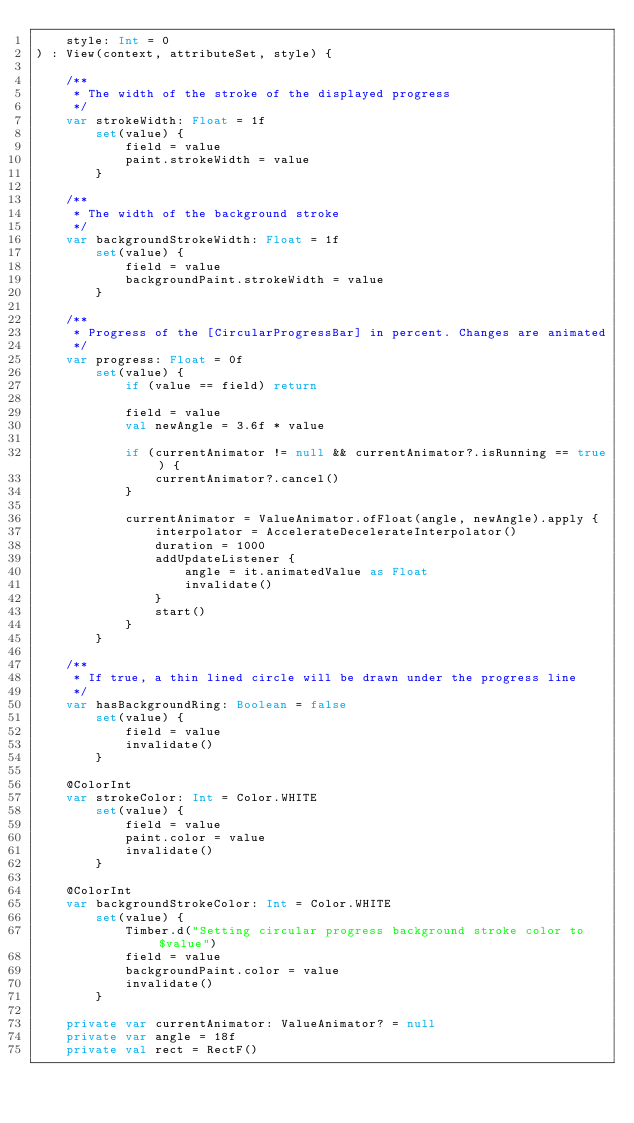<code> <loc_0><loc_0><loc_500><loc_500><_Kotlin_>    style: Int = 0
) : View(context, attributeSet, style) {

    /**
     * The width of the stroke of the displayed progress
     */
    var strokeWidth: Float = 1f
        set(value) {
            field = value
            paint.strokeWidth = value
        }

    /**
     * The width of the background stroke
     */
    var backgroundStrokeWidth: Float = 1f
        set(value) {
            field = value
            backgroundPaint.strokeWidth = value
        }

    /**
     * Progress of the [CircularProgressBar] in percent. Changes are animated
     */
    var progress: Float = 0f
        set(value) {
            if (value == field) return

            field = value
            val newAngle = 3.6f * value

            if (currentAnimator != null && currentAnimator?.isRunning == true) {
                currentAnimator?.cancel()
            }

            currentAnimator = ValueAnimator.ofFloat(angle, newAngle).apply {
                interpolator = AccelerateDecelerateInterpolator()
                duration = 1000
                addUpdateListener {
                    angle = it.animatedValue as Float
                    invalidate()
                }
                start()
            }
        }

    /**
     * If true, a thin lined circle will be drawn under the progress line
     */
    var hasBackgroundRing: Boolean = false
        set(value) {
            field = value
            invalidate()
        }

    @ColorInt
    var strokeColor: Int = Color.WHITE
        set(value) {
            field = value
            paint.color = value
            invalidate()
        }

    @ColorInt
    var backgroundStrokeColor: Int = Color.WHITE
        set(value) {
            Timber.d("Setting circular progress background stroke color to $value")
            field = value
            backgroundPaint.color = value
            invalidate()
        }

    private var currentAnimator: ValueAnimator? = null
    private var angle = 18f
    private val rect = RectF()
</code> 